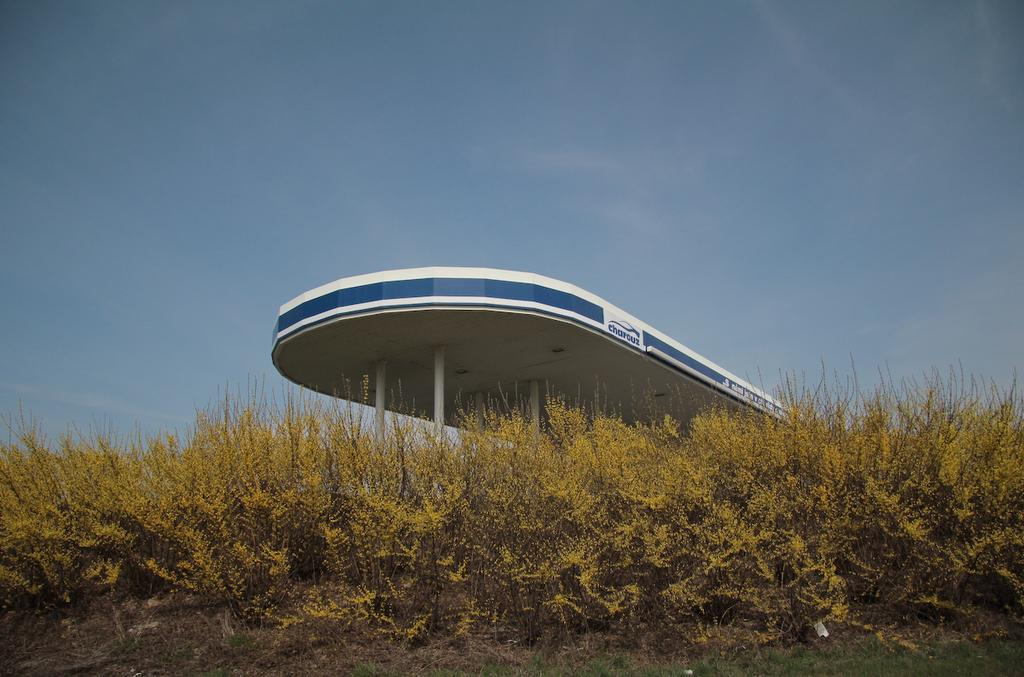What type of living organisms can be seen in the image? Plants can be seen in the image. What structure is present in the image? There is a pole in the image. What part of a building is visible in the image? The roof is visible in the image. What color is the sky in the image? The sky is blue in the image. How many rings are visible on the elbow of the person in the image? There is no person present in the image, so there are no rings or elbows visible. 